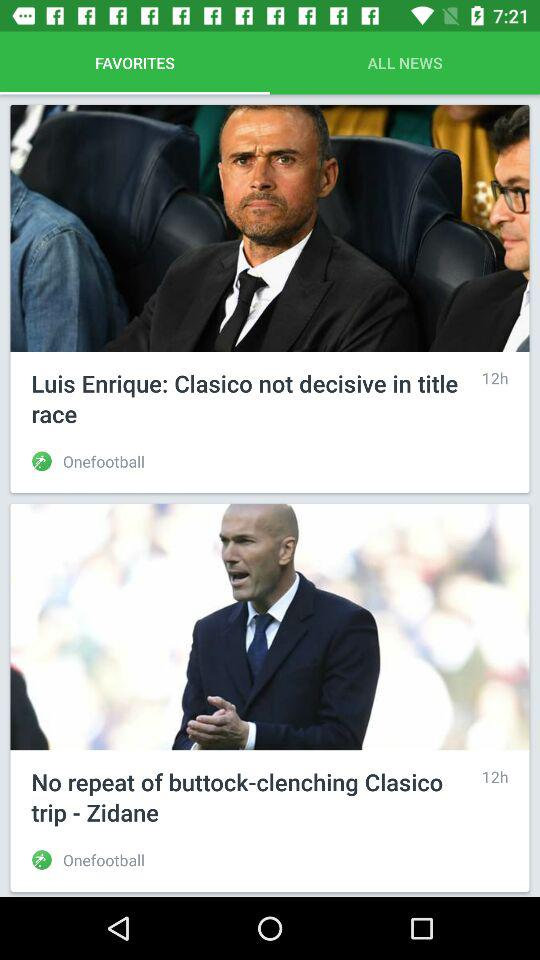How many news items are there?
Answer the question using a single word or phrase. 2 